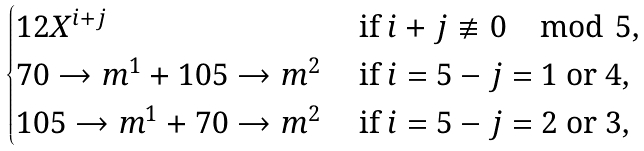Convert formula to latex. <formula><loc_0><loc_0><loc_500><loc_500>\begin{cases} 1 2 X ^ { i + j } & \text { if } i + j \not \equiv 0 \mod 5 , \\ 7 0 \to m ^ { 1 } + 1 0 5 \to m ^ { 2 } & \text { if } i = 5 - j = 1 \text { or } 4 , \\ 1 0 5 \to m ^ { 1 } + 7 0 \to m ^ { 2 } & \text { if } i = 5 - j = 2 \text { or } 3 , \end{cases}</formula> 